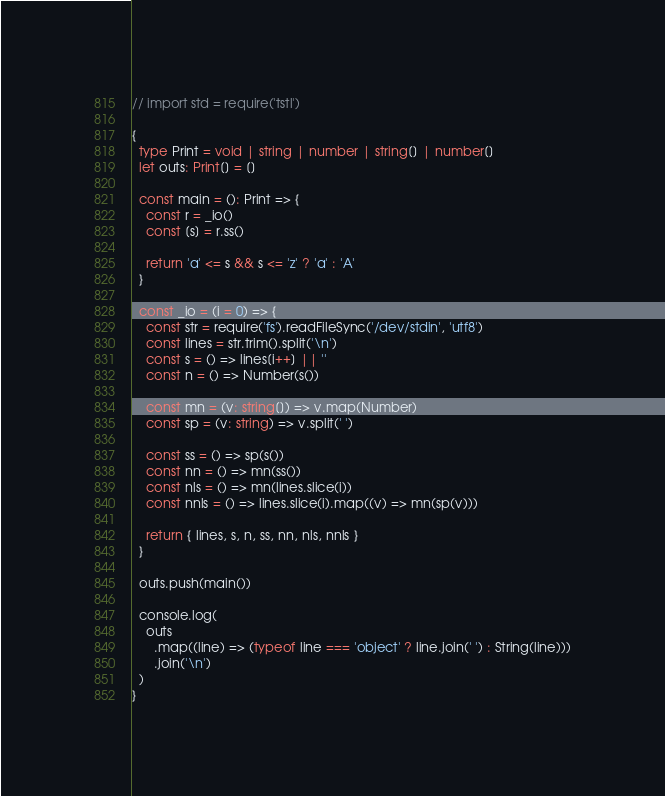Convert code to text. <code><loc_0><loc_0><loc_500><loc_500><_TypeScript_>// import std = require('tstl')

{
  type Print = void | string | number | string[] | number[]
  let outs: Print[] = []

  const main = (): Print => {
    const r = _io()
    const [s] = r.ss()

    return 'a' <= s && s <= 'z' ? 'a' : 'A'
  }

  const _io = (i = 0) => {
    const str = require('fs').readFileSync('/dev/stdin', 'utf8')
    const lines = str.trim().split('\n')
    const s = () => lines[i++] || ''
    const n = () => Number(s())

    const mn = (v: string[]) => v.map(Number)
    const sp = (v: string) => v.split(' ')

    const ss = () => sp(s())
    const nn = () => mn(ss())
    const nls = () => mn(lines.slice(i))
    const nnls = () => lines.slice(i).map((v) => mn(sp(v)))

    return { lines, s, n, ss, nn, nls, nnls }
  }

  outs.push(main())

  console.log(
    outs
      .map((line) => (typeof line === 'object' ? line.join(' ') : String(line)))
      .join('\n')
  )
}
</code> 